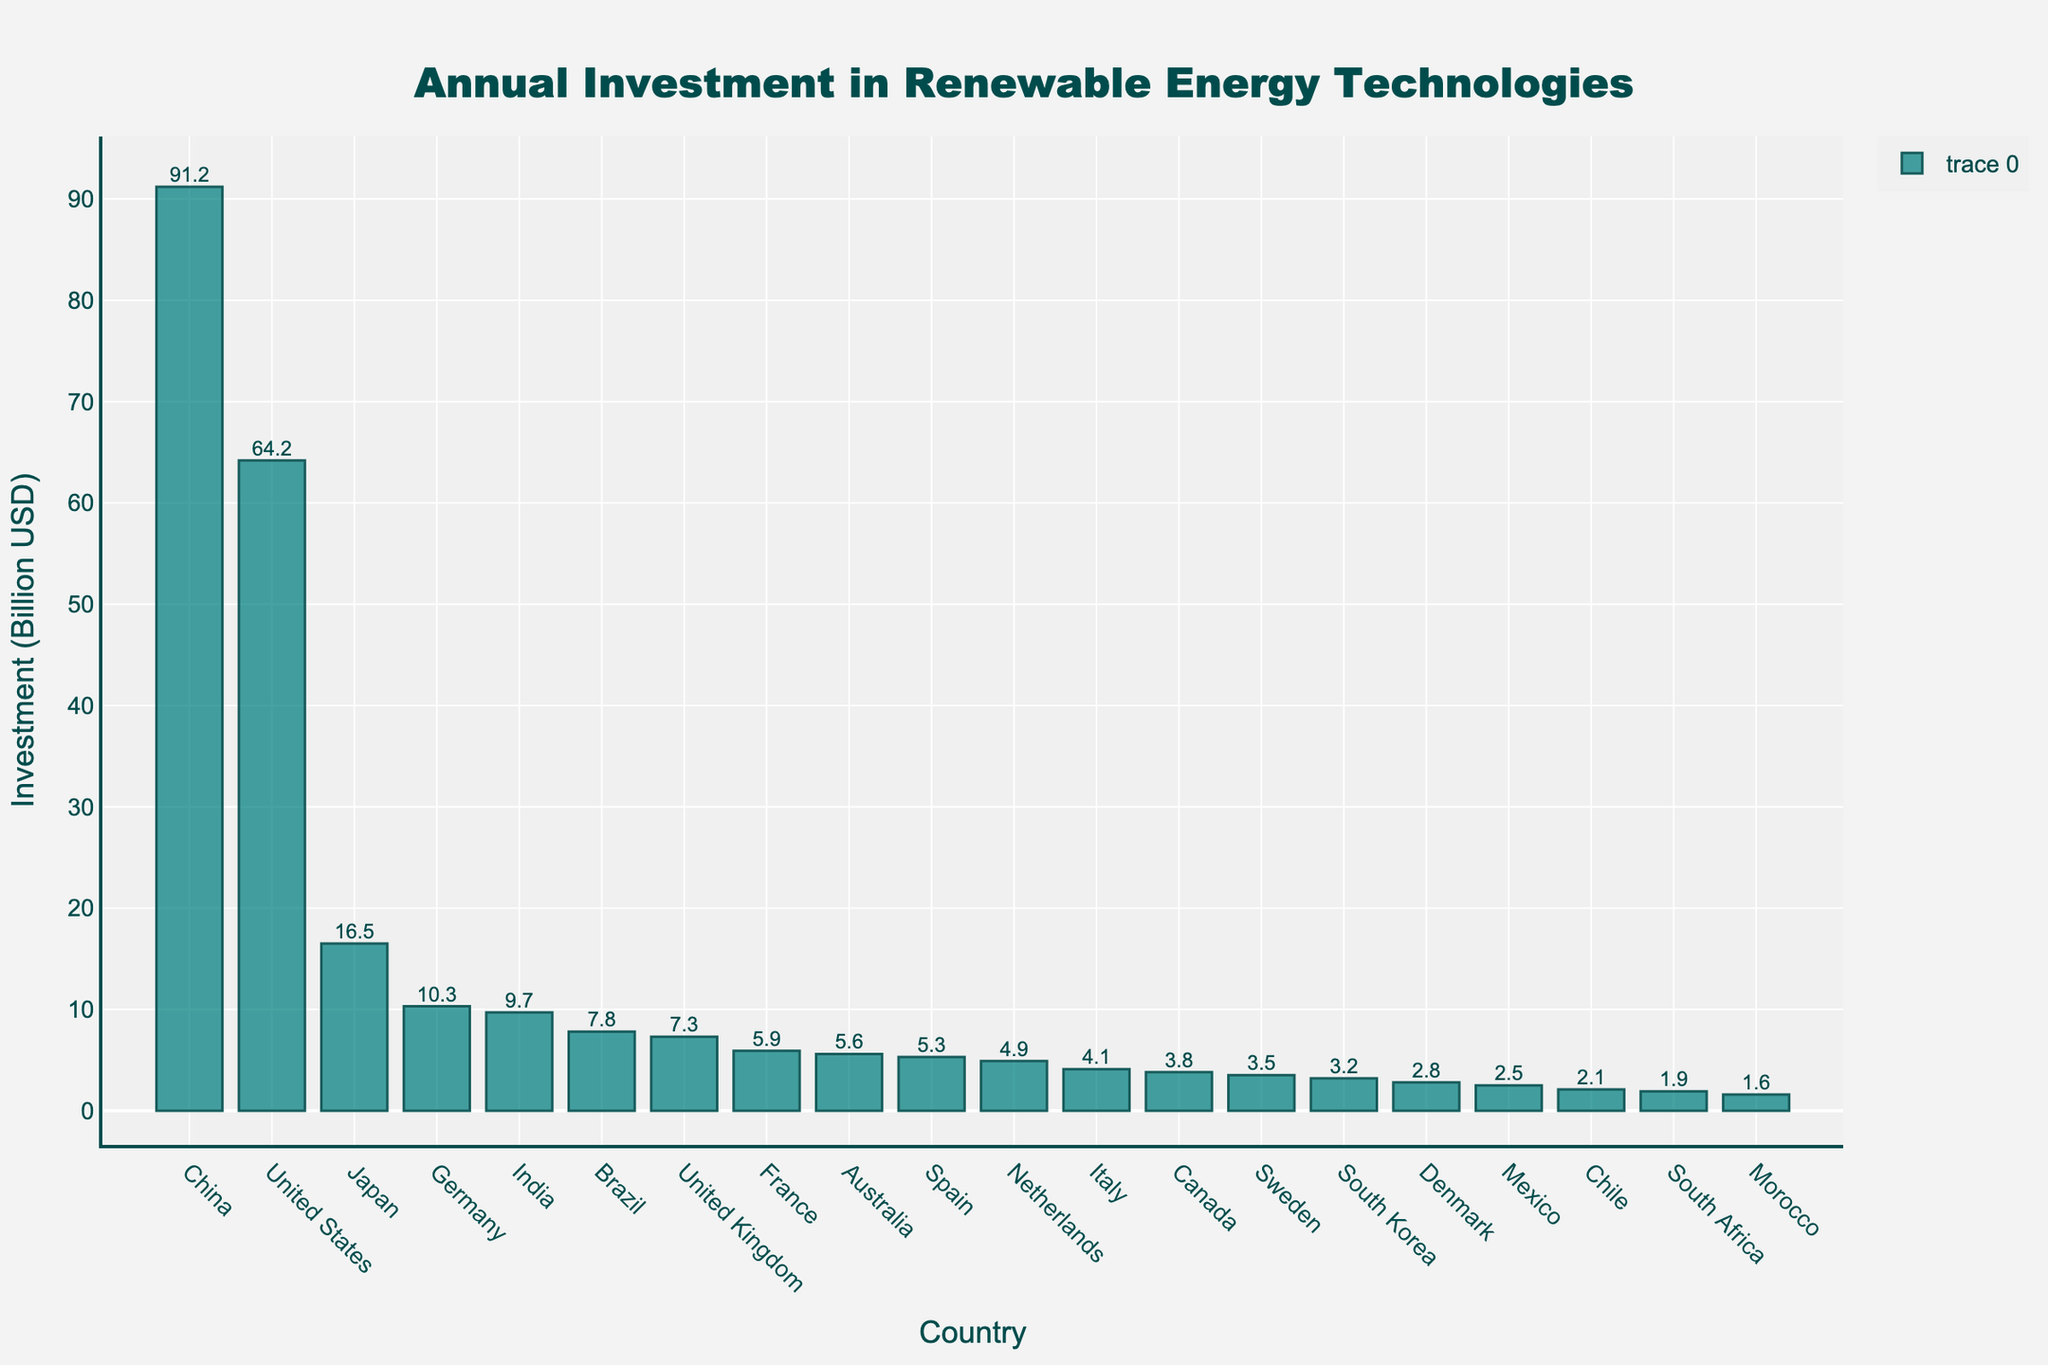Which country has the highest annual investment in renewable energy technologies? The tallest bar in the chart represents the country with the highest investment. In this case, it's China.
Answer: China How much more does the United States invest compared to Japan? Subtract Japan's investment value from the United States' investment value: 64.2 - 16.5 = 47.7 billion USD.
Answer: 47.7 billion USD What is the total investment of the top three countries combined? Add the investment values of China, United States, and Japan: 91.2 + 64.2 + 16.5 = 171.9 billion USD.
Answer: 171.9 billion USD How does Germany's investment compare to India's? Compare the investment values: Germany invests 10.3 billion USD, and India invests 9.7 billion USD. 10.3 is slightly more than 9.7.
Answer: Germany invests more Which two countries have the closest investment values, and what are those values? Look for the bars with the most similar heights. Denmark and Mexico have the closest values, at 2.8 and 2.5 billion USD respectively.
Answer: Denmark and Mexico at 2.8 and 2.5 billion USD What is the average investment of the five countries with the lowest investment? Average the investment values of Morocco, South Africa, Chile, Mexico, and Denmark: (1.6 + 1.9 + 2.1 + 2.5 + 2.8) / 5 = 2.18 billion USD.
Answer: 2.18 billion USD Which country is just below Australia in terms of investment, and what is the numerical difference? The country just below Australia is Spain. Subtract Spain's investment (5.3) from Australia's (5.6): 5.6 - 5.3 = 0.3 billion USD.
Answer: Spain, 0.3 billion USD How many countries have an investment greater than 10 billion USD? Count the bars representing values greater than 10 billion USD. The countries are China, United States, Japan, and Germany (4 countries).
Answer: 4 countries 